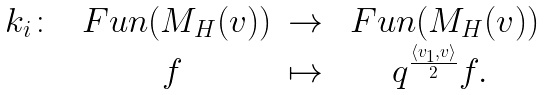Convert formula to latex. <formula><loc_0><loc_0><loc_500><loc_500>\begin{matrix} k _ { i } \colon & \ F u n ( M _ { H } ( v ) ) & \to & \ F u n ( M _ { H } ( v ) ) \\ & f & \mapsto & q ^ { \frac { \langle v _ { 1 } , v \rangle } { 2 } } f . \end{matrix}</formula> 